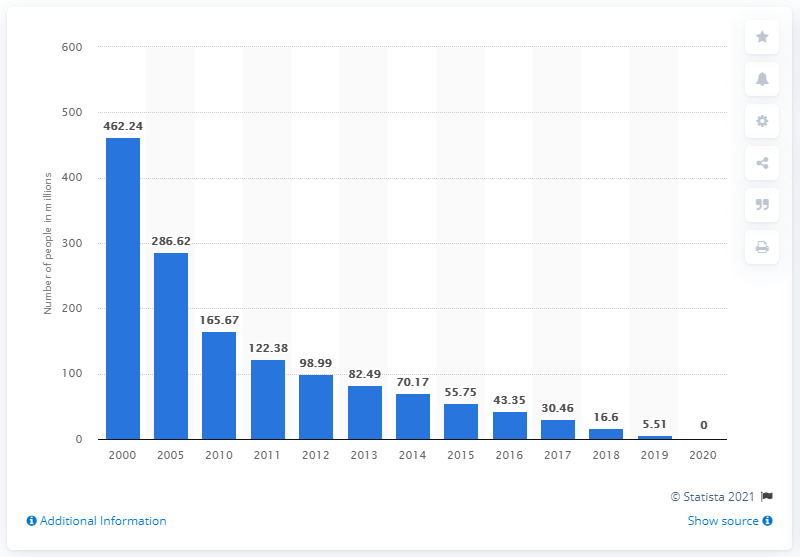Give some essential details in this illustration. The Chinese government announced in 2020 that all of its residents had been relieved from extreme poverty. Since 2000, poverty in rural China has been steadily decreasing. 